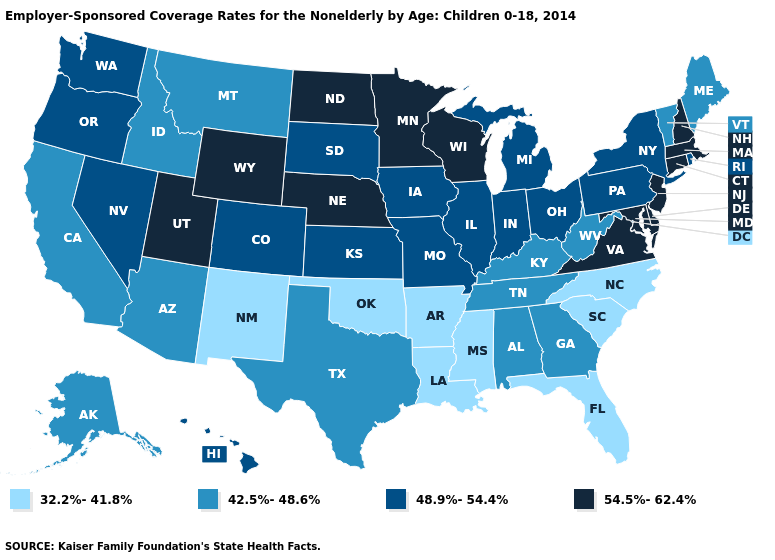How many symbols are there in the legend?
Quick response, please. 4. Which states have the highest value in the USA?
Be succinct. Connecticut, Delaware, Maryland, Massachusetts, Minnesota, Nebraska, New Hampshire, New Jersey, North Dakota, Utah, Virginia, Wisconsin, Wyoming. What is the highest value in the Northeast ?
Concise answer only. 54.5%-62.4%. Which states have the lowest value in the South?
Write a very short answer. Arkansas, Florida, Louisiana, Mississippi, North Carolina, Oklahoma, South Carolina. Name the states that have a value in the range 42.5%-48.6%?
Give a very brief answer. Alabama, Alaska, Arizona, California, Georgia, Idaho, Kentucky, Maine, Montana, Tennessee, Texas, Vermont, West Virginia. Name the states that have a value in the range 48.9%-54.4%?
Answer briefly. Colorado, Hawaii, Illinois, Indiana, Iowa, Kansas, Michigan, Missouri, Nevada, New York, Ohio, Oregon, Pennsylvania, Rhode Island, South Dakota, Washington. What is the lowest value in the West?
Be succinct. 32.2%-41.8%. Name the states that have a value in the range 42.5%-48.6%?
Be succinct. Alabama, Alaska, Arizona, California, Georgia, Idaho, Kentucky, Maine, Montana, Tennessee, Texas, Vermont, West Virginia. Among the states that border Arizona , does California have the lowest value?
Concise answer only. No. How many symbols are there in the legend?
Be succinct. 4. Does Massachusetts have a higher value than Virginia?
Give a very brief answer. No. Which states have the lowest value in the West?
Answer briefly. New Mexico. Does Mississippi have a higher value than Massachusetts?
Write a very short answer. No. Among the states that border Wyoming , which have the highest value?
Be succinct. Nebraska, Utah. Does the first symbol in the legend represent the smallest category?
Short answer required. Yes. 